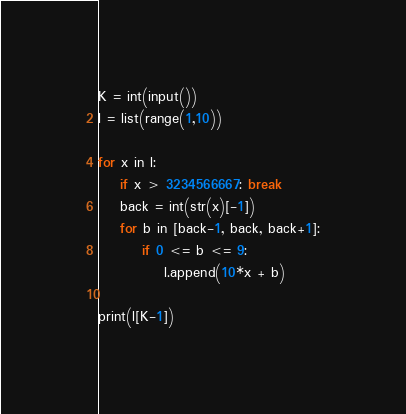Convert code to text. <code><loc_0><loc_0><loc_500><loc_500><_Python_>K = int(input())
l = list(range(1,10))

for x in l:
    if x > 3234566667: break
    back = int(str(x)[-1])
    for b in [back-1, back, back+1]:
        if 0 <= b <= 9:
            l.append(10*x + b)

print(l[K-1])</code> 